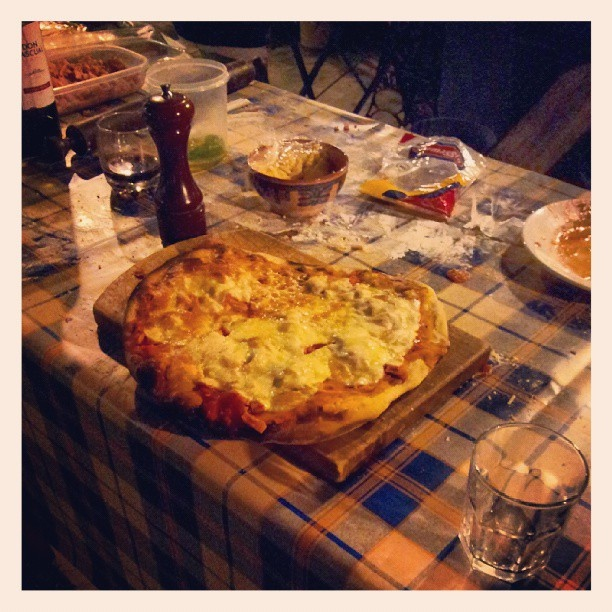Describe the objects in this image and their specific colors. I can see dining table in white, brown, maroon, and tan tones, pizza in white, orange, red, and maroon tones, cup in white, tan, brown, maroon, and black tones, bowl in white, maroon, tan, brown, and black tones, and bowl in ivory, tan, brown, and red tones in this image. 